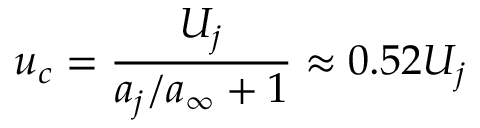<formula> <loc_0><loc_0><loc_500><loc_500>u _ { c } = \frac { U _ { j } } { a _ { j } / a _ { \infty } + 1 } \approx 0 . 5 2 U _ { j }</formula> 